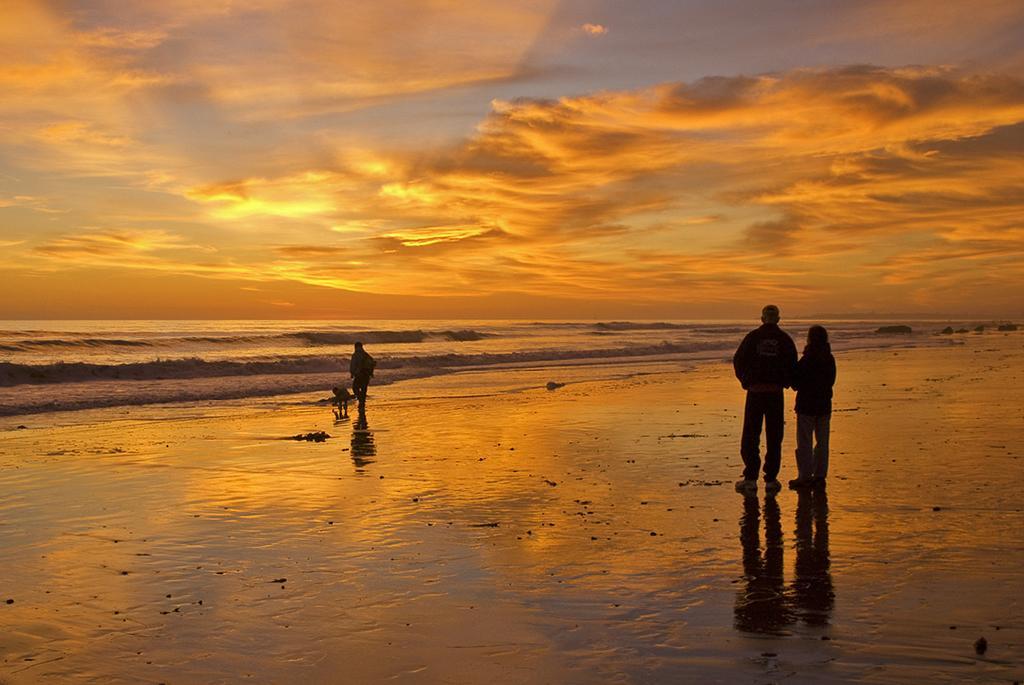Can you describe this image briefly? This is a beach. On the right side there are two persons standing facing towards the back side. On the left side a person and a child are standing. In the background there is an ocean. At the top of the image I can see the sky and clouds. 